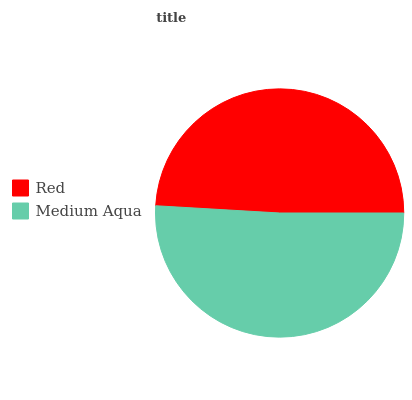Is Red the minimum?
Answer yes or no. Yes. Is Medium Aqua the maximum?
Answer yes or no. Yes. Is Medium Aqua the minimum?
Answer yes or no. No. Is Medium Aqua greater than Red?
Answer yes or no. Yes. Is Red less than Medium Aqua?
Answer yes or no. Yes. Is Red greater than Medium Aqua?
Answer yes or no. No. Is Medium Aqua less than Red?
Answer yes or no. No. Is Medium Aqua the high median?
Answer yes or no. Yes. Is Red the low median?
Answer yes or no. Yes. Is Red the high median?
Answer yes or no. No. Is Medium Aqua the low median?
Answer yes or no. No. 